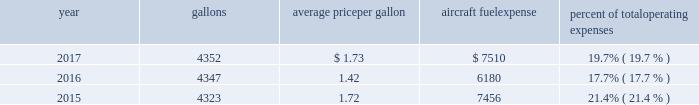( 2 ) our union-represented mainline employees are covered by agreements that are not currently amendable .
Joint collective bargaining agreements ( jcbas ) have been reached with post-merger employee groups , except the maintenance , fleet service , stock clerks , maintenance control technicians and maintenance training instructors represented by the twu-iam association who are covered by separate cbas that become amendable in the third quarter of 2018 .
Until those agreements become amendable , negotiations for jcbas will be conducted outside the traditional rla bargaining process as described above , and , in the meantime , no self-help will be permissible .
( 3 ) among our wholly-owned regional subsidiaries , the psa mechanics and flight attendants have agreements that are now amendable and are engaged in traditional rla negotiations .
The envoy passenger service employees are engaged in traditional rla negotiations for an initial cba .
The piedmont fleet and passenger service employees have reached a tentative five-year agreement which is subject to membership ratification .
For more discussion , see part i , item 1a .
Risk factors 2013 201cunion disputes , employee strikes and other labor-related disruptions may adversely affect our operations . 201d aircraft fuel our operations and financial results are significantly affected by the availability and price of jet fuel , which is our second largest expense .
Based on our 2018 forecasted mainline and regional fuel consumption , we estimate that a one cent per gallon increase in aviation fuel price would increase our 2018 annual fuel expense by $ 45 million .
The table shows annual aircraft fuel consumption and costs , including taxes , for our mainline and regional operations for 2017 , 2016 and 2015 ( gallons and aircraft fuel expense in millions ) .
Year gallons average price per gallon aircraft fuel expense percent of total operating expenses .
As of december 31 , 2017 , we did not have any fuel hedging contracts outstanding to hedge our fuel consumption .
As such , and assuming we do not enter into any future transactions to hedge our fuel consumption , we will continue to be fully exposed to fluctuations in fuel prices .
Our current policy is not to enter into transactions to hedge our fuel consumption , although we review that policy from time to time based on market conditions and other factors .
Fuel prices have fluctuated substantially over the past several years .
We cannot predict the future availability , price volatility or cost of aircraft fuel .
Natural disasters ( including hurricanes or similar events in the u.s .
Southeast and on the gulf coast where a significant portion of domestic refining capacity is located ) , political disruptions or wars involving oil-producing countries , changes in fuel-related governmental policy , the strength of the u.s .
Dollar against foreign currencies , changes in access to petroleum product pipelines and terminals , speculation in the energy futures markets , changes in aircraft fuel production capacity , environmental concerns and other unpredictable events may result in fuel supply shortages , distribution challenges , additional fuel price volatility and cost increases in the future .
See part i , item 1a .
Risk factors 2013 201cour business is very dependent on the price and availability of aircraft fuel .
Continued periods of high volatility in fuel costs , increased fuel prices or significant disruptions in the supply of aircraft fuel could have a significant negative impact on our operating results and liquidity . 201d seasonality and other factors due to the greater demand for air travel during the summer months , revenues in the airline industry in the second and third quarters of the year tend to be greater than revenues in the first and fourth quarters of the year .
General economic conditions , fears of terrorism or war , fare initiatives , fluctuations in fuel prices , labor actions , weather , natural disasters , outbreaks of disease and other factors could impact this seasonal pattern .
Therefore , our quarterly results of operations are not necessarily indicative of operating results for the entire year , and historical operating results in a quarterly or annual period are not necessarily indicative of future operating results. .
As of 2017 what was the total annual fuel expenses starting with 2015 in millions? 
Rationale: the total is the sum of the expenses for each year
Computations: ((6180 + 7510) + 7456)
Answer: 21146.0. 